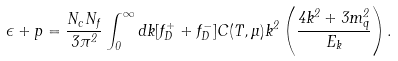Convert formula to latex. <formula><loc_0><loc_0><loc_500><loc_500>\epsilon + p = \frac { N _ { c } N _ { f } } { 3 \pi ^ { 2 } } \int _ { 0 } ^ { \infty } d k [ f _ { D } ^ { + } + f _ { D } ^ { - } ] C ( T , \mu ) k ^ { 2 } \left ( \frac { 4 k ^ { 2 } + 3 m _ { q } ^ { 2 } } { E _ { k } } \right ) .</formula> 